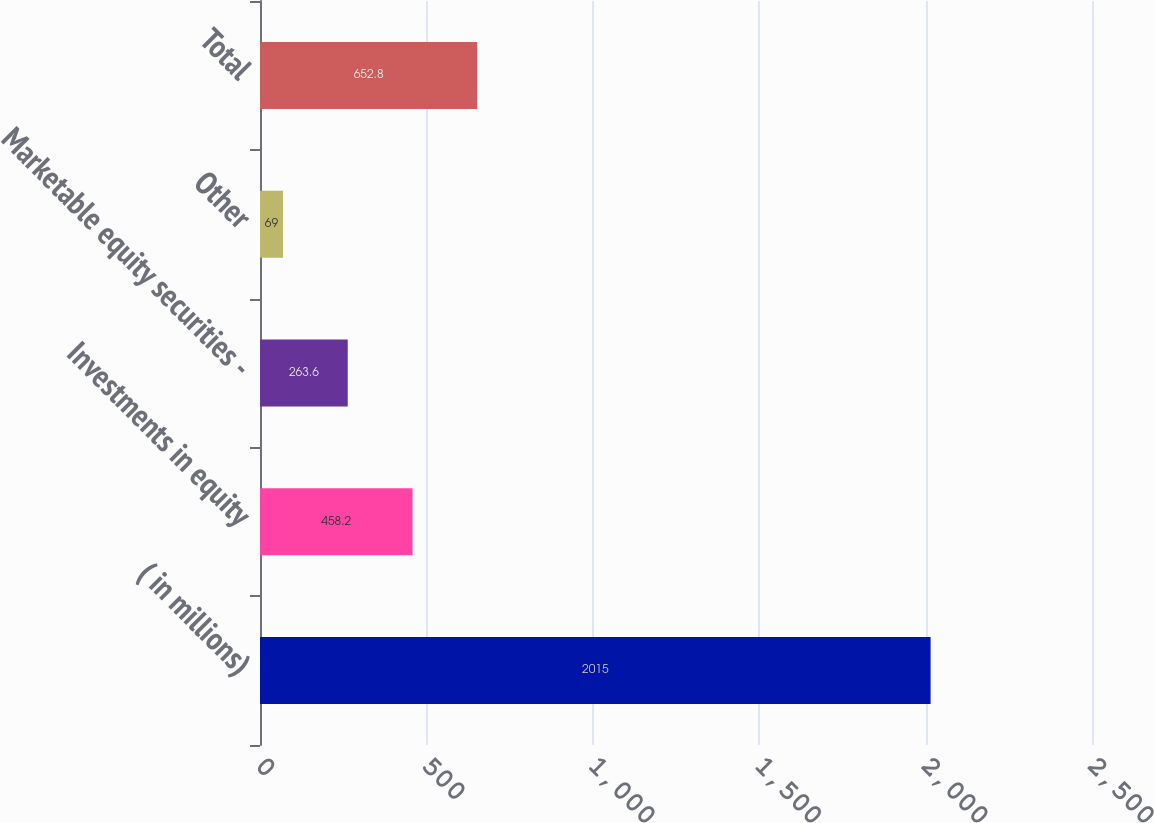Convert chart. <chart><loc_0><loc_0><loc_500><loc_500><bar_chart><fcel>( in millions)<fcel>Investments in equity<fcel>Marketable equity securities -<fcel>Other<fcel>Total<nl><fcel>2015<fcel>458.2<fcel>263.6<fcel>69<fcel>652.8<nl></chart> 